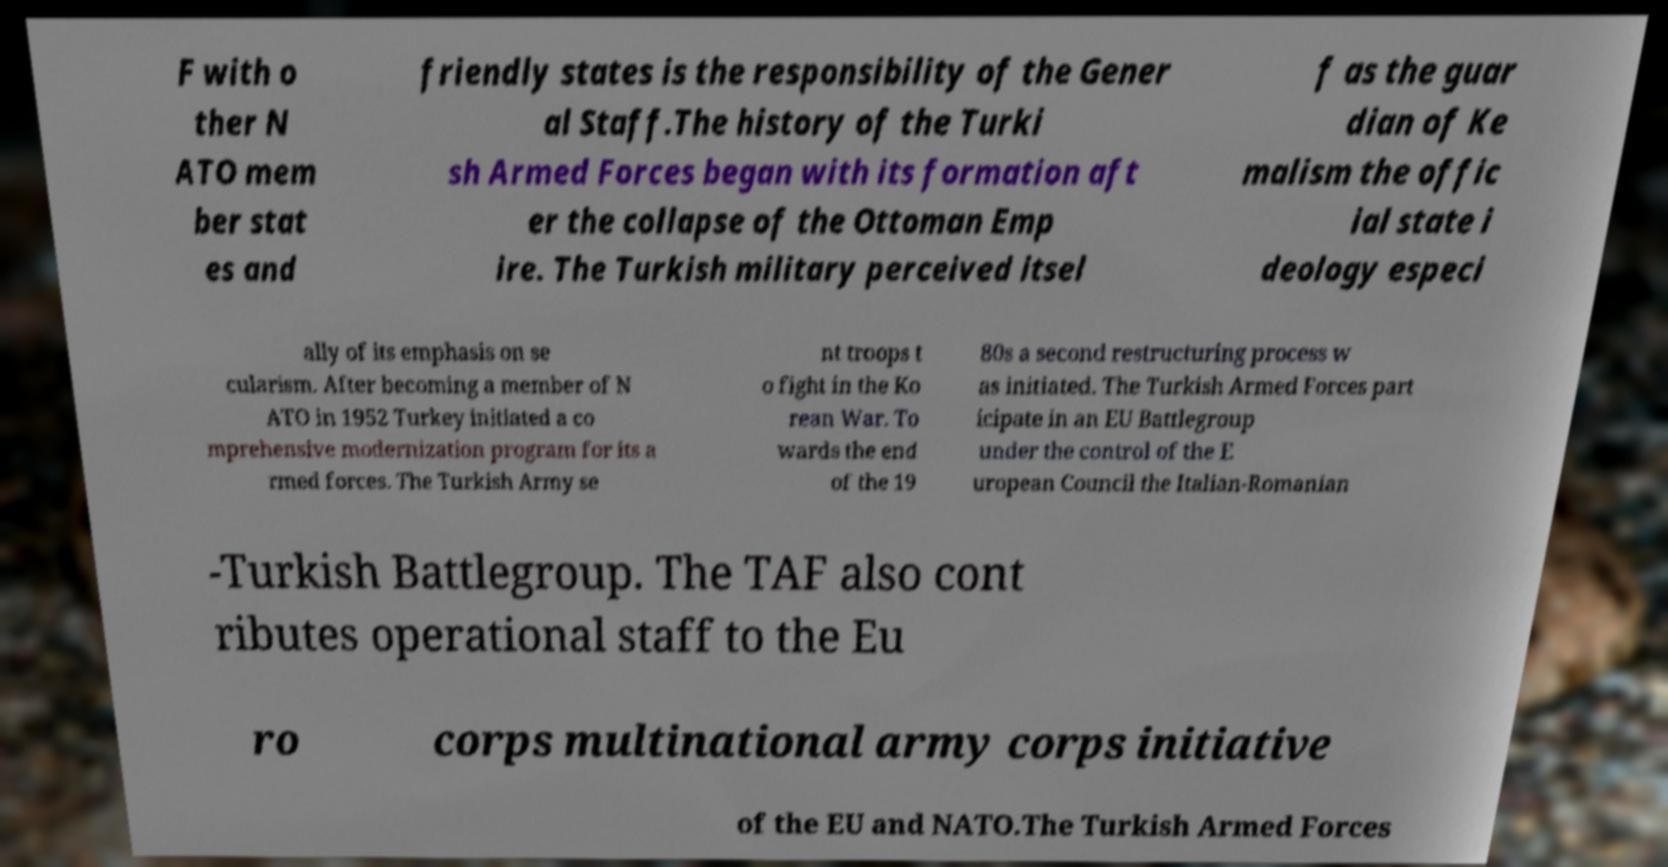What messages or text are displayed in this image? I need them in a readable, typed format. F with o ther N ATO mem ber stat es and friendly states is the responsibility of the Gener al Staff.The history of the Turki sh Armed Forces began with its formation aft er the collapse of the Ottoman Emp ire. The Turkish military perceived itsel f as the guar dian of Ke malism the offic ial state i deology especi ally of its emphasis on se cularism. After becoming a member of N ATO in 1952 Turkey initiated a co mprehensive modernization program for its a rmed forces. The Turkish Army se nt troops t o fight in the Ko rean War. To wards the end of the 19 80s a second restructuring process w as initiated. The Turkish Armed Forces part icipate in an EU Battlegroup under the control of the E uropean Council the Italian-Romanian -Turkish Battlegroup. The TAF also cont ributes operational staff to the Eu ro corps multinational army corps initiative of the EU and NATO.The Turkish Armed Forces 